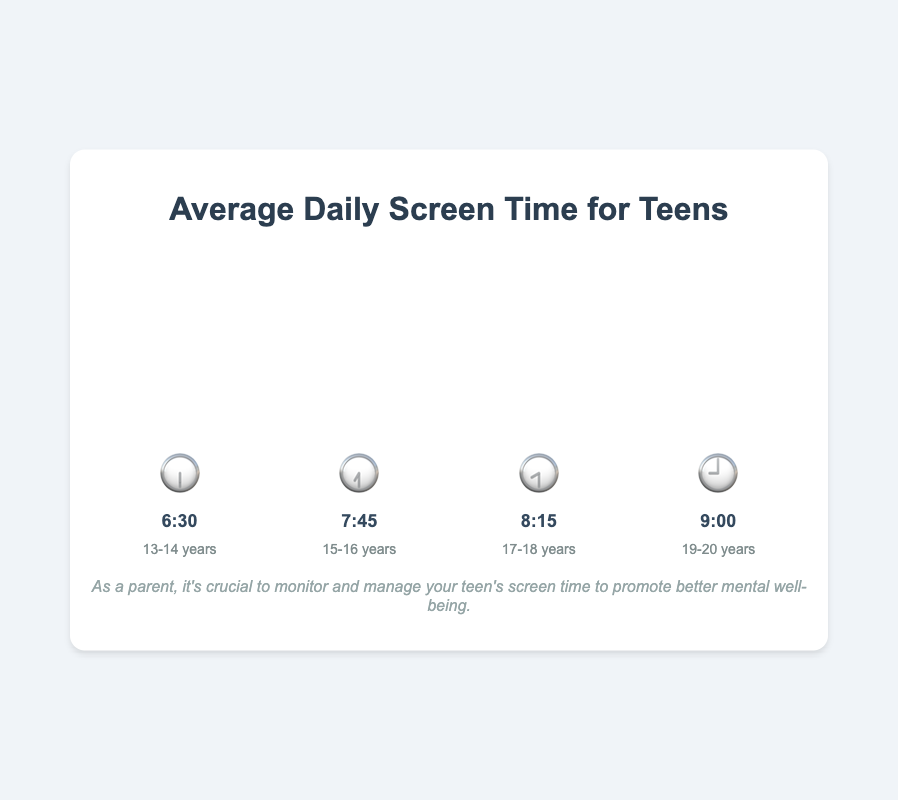What's the screen time for 15-16 years old? In the chart, the bar labeled "15-16 years" shows the emoji 🕢 with the time 7:45.
Answer: 7:45 Which age group has the highest average daily screen time? The highest bar is labeled "19-20 years" with the emoji 🕘 and the time 9:00.
Answer: 19-20 years How much more screen time do 17-18-year-olds have compared to 13-14-year-olds? The screen time for 17-18 years old is 8:15, and for 13-14 years old it's 6:30. To compare, convert these to minutes: 8*60+15 = 495 minutes and 6*60+30 = 390 minutes. The difference is 495 - 390 = 105 minutes.
Answer: 1 hour 45 minutes What is the average screen time across all age groups? Add the times for all groups converted to minutes: (6*60+30) + (7*60+45) + (8*60+15) + (9*60) = 390 + 465 + 495 + 540 = 1890. Then, divide by 4: 1890/4 = 472.5 minutes, which converts back to 7 hours and 52 minutes.
Answer: 7 hours 52 minutes Which age group has the least screen time? The shortest bar in the chart is labeled "13-14 years" with the emoji 🕡 and the time 6:30.
Answer: 13-14 years How does the screen time for 15-16-year-olds compare to that of 19-20-year-olds? The screen time for 15-16 years old is 7:45 and for 19-20 years old is 9:00. Converting to minutes: 7*60+45 = 465 and 9*60 = 540. Thus, 19-20 years old have 540 - 465 = 75 minutes more.
Answer: 1 hour 15 minutes more What's the total screen time for the age groups 13-14 and 15-16 combined? Convert screen times to minutes and sum them: (6*60+30) + (7*60+45) = 390 + 465 = 855 minutes, which equals 14 hours and 15 minutes.
Answer: 14 hours 15 minutes If we group 13-18 years old together, what's their average screen time? Sum the times for 13-14, 15-16, and 17-18 age groups in minutes: (6*60+30) + (7*60+45) + (8*60+15) = 390 + 465 + 495 = 1350. Divide by 3: 1350/3 = 450 minutes. Converting back to hours: 7 hours and 30 minutes.
Answer: 7 hours 30 minutes 